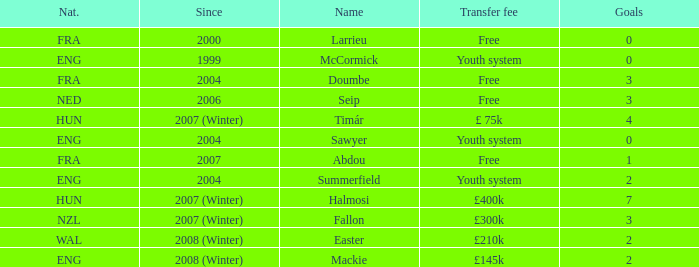What is the starting year of the player with a transfer fee of £ 75k? 2007 (Winter). 